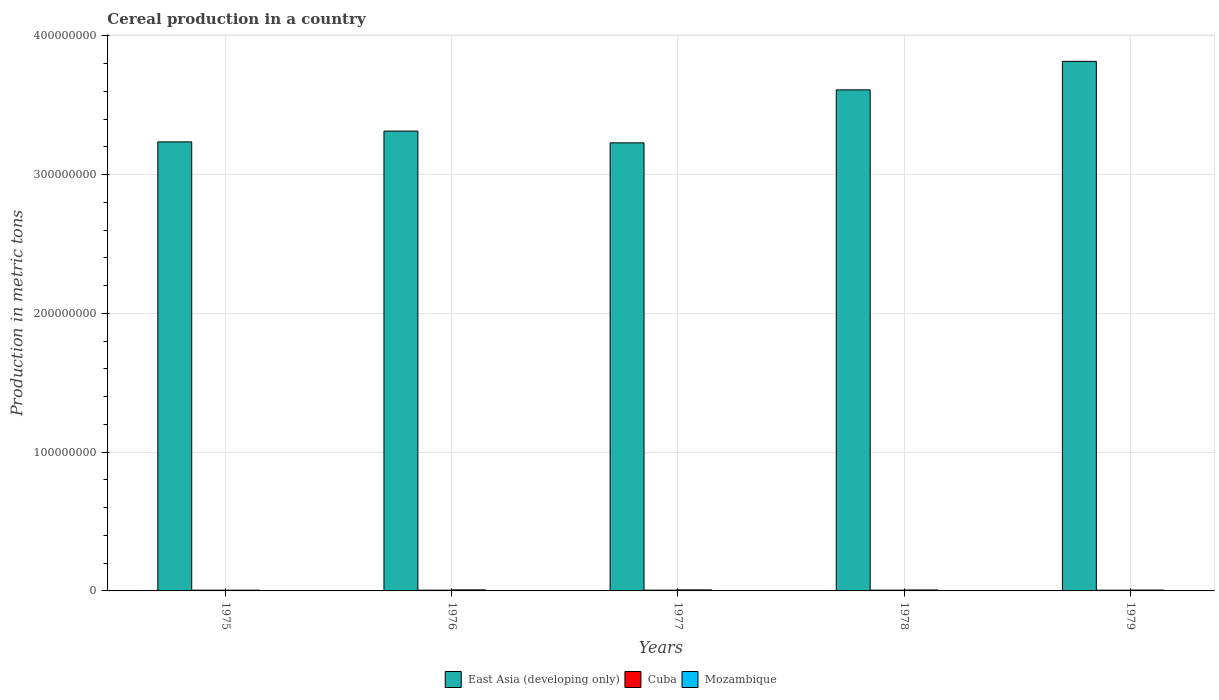Are the number of bars per tick equal to the number of legend labels?
Make the answer very short. Yes. What is the label of the 1st group of bars from the left?
Your answer should be compact. 1975. What is the total cereal production in East Asia (developing only) in 1976?
Your answer should be compact. 3.31e+08. Across all years, what is the maximum total cereal production in Cuba?
Provide a short and direct response. 5.54e+05. Across all years, what is the minimum total cereal production in East Asia (developing only)?
Provide a short and direct response. 3.23e+08. In which year was the total cereal production in East Asia (developing only) maximum?
Provide a succinct answer. 1979. In which year was the total cereal production in Mozambique minimum?
Keep it short and to the point. 1975. What is the total total cereal production in Cuba in the graph?
Your response must be concise. 2.71e+06. What is the difference between the total cereal production in Cuba in 1976 and that in 1978?
Provide a short and direct response. -7380. What is the difference between the total cereal production in East Asia (developing only) in 1977 and the total cereal production in Mozambique in 1978?
Give a very brief answer. 3.22e+08. What is the average total cereal production in Cuba per year?
Offer a very short reply. 5.43e+05. In the year 1975, what is the difference between the total cereal production in Mozambique and total cereal production in Cuba?
Offer a very short reply. 654. In how many years, is the total cereal production in Cuba greater than 220000000 metric tons?
Offer a very short reply. 0. What is the ratio of the total cereal production in East Asia (developing only) in 1976 to that in 1977?
Offer a very short reply. 1.03. Is the difference between the total cereal production in Mozambique in 1975 and 1977 greater than the difference between the total cereal production in Cuba in 1975 and 1977?
Keep it short and to the point. No. What is the difference between the highest and the second highest total cereal production in Mozambique?
Offer a very short reply. 1.80e+04. What is the difference between the highest and the lowest total cereal production in East Asia (developing only)?
Your answer should be compact. 5.87e+07. Is the sum of the total cereal production in Cuba in 1975 and 1976 greater than the maximum total cereal production in East Asia (developing only) across all years?
Make the answer very short. No. What does the 3rd bar from the left in 1978 represents?
Your answer should be compact. Mozambique. What does the 1st bar from the right in 1977 represents?
Offer a very short reply. Mozambique. Are all the bars in the graph horizontal?
Keep it short and to the point. No. How many years are there in the graph?
Your answer should be very brief. 5. What is the difference between two consecutive major ticks on the Y-axis?
Your answer should be compact. 1.00e+08. Are the values on the major ticks of Y-axis written in scientific E-notation?
Make the answer very short. No. Does the graph contain any zero values?
Give a very brief answer. No. How are the legend labels stacked?
Your answer should be very brief. Horizontal. What is the title of the graph?
Provide a succinct answer. Cereal production in a country. Does "Bolivia" appear as one of the legend labels in the graph?
Ensure brevity in your answer.  No. What is the label or title of the X-axis?
Your answer should be compact. Years. What is the label or title of the Y-axis?
Your answer should be compact. Production in metric tons. What is the Production in metric tons of East Asia (developing only) in 1975?
Your response must be concise. 3.24e+08. What is the Production in metric tons in Cuba in 1975?
Keep it short and to the point. 5.41e+05. What is the Production in metric tons in Mozambique in 1975?
Ensure brevity in your answer.  5.42e+05. What is the Production in metric tons of East Asia (developing only) in 1976?
Provide a short and direct response. 3.31e+08. What is the Production in metric tons in Cuba in 1976?
Your response must be concise. 5.46e+05. What is the Production in metric tons in Mozambique in 1976?
Provide a succinct answer. 7.56e+05. What is the Production in metric tons of East Asia (developing only) in 1977?
Give a very brief answer. 3.23e+08. What is the Production in metric tons in Cuba in 1977?
Your answer should be compact. 5.52e+05. What is the Production in metric tons of Mozambique in 1977?
Your response must be concise. 7.38e+05. What is the Production in metric tons of East Asia (developing only) in 1978?
Ensure brevity in your answer.  3.61e+08. What is the Production in metric tons in Cuba in 1978?
Ensure brevity in your answer.  5.54e+05. What is the Production in metric tons in Mozambique in 1978?
Give a very brief answer. 6.82e+05. What is the Production in metric tons of East Asia (developing only) in 1979?
Keep it short and to the point. 3.82e+08. What is the Production in metric tons in Cuba in 1979?
Offer a terse response. 5.21e+05. What is the Production in metric tons in Mozambique in 1979?
Ensure brevity in your answer.  6.22e+05. Across all years, what is the maximum Production in metric tons in East Asia (developing only)?
Offer a very short reply. 3.82e+08. Across all years, what is the maximum Production in metric tons in Cuba?
Offer a terse response. 5.54e+05. Across all years, what is the maximum Production in metric tons in Mozambique?
Your answer should be compact. 7.56e+05. Across all years, what is the minimum Production in metric tons in East Asia (developing only)?
Keep it short and to the point. 3.23e+08. Across all years, what is the minimum Production in metric tons in Cuba?
Give a very brief answer. 5.21e+05. Across all years, what is the minimum Production in metric tons of Mozambique?
Provide a succinct answer. 5.42e+05. What is the total Production in metric tons in East Asia (developing only) in the graph?
Ensure brevity in your answer.  1.72e+09. What is the total Production in metric tons in Cuba in the graph?
Your response must be concise. 2.71e+06. What is the total Production in metric tons in Mozambique in the graph?
Provide a short and direct response. 3.34e+06. What is the difference between the Production in metric tons in East Asia (developing only) in 1975 and that in 1976?
Offer a very short reply. -7.76e+06. What is the difference between the Production in metric tons of Cuba in 1975 and that in 1976?
Your answer should be very brief. -4832. What is the difference between the Production in metric tons of Mozambique in 1975 and that in 1976?
Offer a very short reply. -2.14e+05. What is the difference between the Production in metric tons in East Asia (developing only) in 1975 and that in 1977?
Provide a succinct answer. 6.87e+05. What is the difference between the Production in metric tons in Cuba in 1975 and that in 1977?
Your response must be concise. -1.05e+04. What is the difference between the Production in metric tons of Mozambique in 1975 and that in 1977?
Your response must be concise. -1.96e+05. What is the difference between the Production in metric tons in East Asia (developing only) in 1975 and that in 1978?
Your response must be concise. -3.75e+07. What is the difference between the Production in metric tons in Cuba in 1975 and that in 1978?
Your answer should be very brief. -1.22e+04. What is the difference between the Production in metric tons in East Asia (developing only) in 1975 and that in 1979?
Offer a very short reply. -5.80e+07. What is the difference between the Production in metric tons of Cuba in 1975 and that in 1979?
Provide a succinct answer. 2.01e+04. What is the difference between the Production in metric tons in Mozambique in 1975 and that in 1979?
Provide a succinct answer. -7.99e+04. What is the difference between the Production in metric tons in East Asia (developing only) in 1976 and that in 1977?
Offer a terse response. 8.45e+06. What is the difference between the Production in metric tons in Cuba in 1976 and that in 1977?
Ensure brevity in your answer.  -5696. What is the difference between the Production in metric tons of Mozambique in 1976 and that in 1977?
Provide a short and direct response. 1.80e+04. What is the difference between the Production in metric tons of East Asia (developing only) in 1976 and that in 1978?
Ensure brevity in your answer.  -2.97e+07. What is the difference between the Production in metric tons of Cuba in 1976 and that in 1978?
Your answer should be compact. -7380. What is the difference between the Production in metric tons of Mozambique in 1976 and that in 1978?
Your answer should be compact. 7.40e+04. What is the difference between the Production in metric tons in East Asia (developing only) in 1976 and that in 1979?
Provide a short and direct response. -5.03e+07. What is the difference between the Production in metric tons of Cuba in 1976 and that in 1979?
Provide a short and direct response. 2.50e+04. What is the difference between the Production in metric tons of Mozambique in 1976 and that in 1979?
Give a very brief answer. 1.34e+05. What is the difference between the Production in metric tons in East Asia (developing only) in 1977 and that in 1978?
Your response must be concise. -3.82e+07. What is the difference between the Production in metric tons of Cuba in 1977 and that in 1978?
Your answer should be compact. -1684. What is the difference between the Production in metric tons in Mozambique in 1977 and that in 1978?
Your answer should be very brief. 5.60e+04. What is the difference between the Production in metric tons of East Asia (developing only) in 1977 and that in 1979?
Provide a short and direct response. -5.87e+07. What is the difference between the Production in metric tons in Cuba in 1977 and that in 1979?
Give a very brief answer. 3.07e+04. What is the difference between the Production in metric tons of Mozambique in 1977 and that in 1979?
Provide a succinct answer. 1.16e+05. What is the difference between the Production in metric tons of East Asia (developing only) in 1978 and that in 1979?
Offer a very short reply. -2.06e+07. What is the difference between the Production in metric tons in Cuba in 1978 and that in 1979?
Make the answer very short. 3.24e+04. What is the difference between the Production in metric tons in Mozambique in 1978 and that in 1979?
Make the answer very short. 6.01e+04. What is the difference between the Production in metric tons of East Asia (developing only) in 1975 and the Production in metric tons of Cuba in 1976?
Offer a very short reply. 3.23e+08. What is the difference between the Production in metric tons in East Asia (developing only) in 1975 and the Production in metric tons in Mozambique in 1976?
Offer a very short reply. 3.23e+08. What is the difference between the Production in metric tons in Cuba in 1975 and the Production in metric tons in Mozambique in 1976?
Make the answer very short. -2.15e+05. What is the difference between the Production in metric tons in East Asia (developing only) in 1975 and the Production in metric tons in Cuba in 1977?
Make the answer very short. 3.23e+08. What is the difference between the Production in metric tons of East Asia (developing only) in 1975 and the Production in metric tons of Mozambique in 1977?
Your answer should be compact. 3.23e+08. What is the difference between the Production in metric tons of Cuba in 1975 and the Production in metric tons of Mozambique in 1977?
Offer a terse response. -1.97e+05. What is the difference between the Production in metric tons in East Asia (developing only) in 1975 and the Production in metric tons in Cuba in 1978?
Provide a short and direct response. 3.23e+08. What is the difference between the Production in metric tons in East Asia (developing only) in 1975 and the Production in metric tons in Mozambique in 1978?
Offer a very short reply. 3.23e+08. What is the difference between the Production in metric tons in Cuba in 1975 and the Production in metric tons in Mozambique in 1978?
Keep it short and to the point. -1.41e+05. What is the difference between the Production in metric tons of East Asia (developing only) in 1975 and the Production in metric tons of Cuba in 1979?
Provide a succinct answer. 3.23e+08. What is the difference between the Production in metric tons in East Asia (developing only) in 1975 and the Production in metric tons in Mozambique in 1979?
Give a very brief answer. 3.23e+08. What is the difference between the Production in metric tons of Cuba in 1975 and the Production in metric tons of Mozambique in 1979?
Keep it short and to the point. -8.06e+04. What is the difference between the Production in metric tons of East Asia (developing only) in 1976 and the Production in metric tons of Cuba in 1977?
Your response must be concise. 3.31e+08. What is the difference between the Production in metric tons in East Asia (developing only) in 1976 and the Production in metric tons in Mozambique in 1977?
Your answer should be very brief. 3.31e+08. What is the difference between the Production in metric tons in Cuba in 1976 and the Production in metric tons in Mozambique in 1977?
Offer a very short reply. -1.92e+05. What is the difference between the Production in metric tons of East Asia (developing only) in 1976 and the Production in metric tons of Cuba in 1978?
Keep it short and to the point. 3.31e+08. What is the difference between the Production in metric tons of East Asia (developing only) in 1976 and the Production in metric tons of Mozambique in 1978?
Give a very brief answer. 3.31e+08. What is the difference between the Production in metric tons of Cuba in 1976 and the Production in metric tons of Mozambique in 1978?
Keep it short and to the point. -1.36e+05. What is the difference between the Production in metric tons in East Asia (developing only) in 1976 and the Production in metric tons in Cuba in 1979?
Offer a very short reply. 3.31e+08. What is the difference between the Production in metric tons of East Asia (developing only) in 1976 and the Production in metric tons of Mozambique in 1979?
Your answer should be very brief. 3.31e+08. What is the difference between the Production in metric tons of Cuba in 1976 and the Production in metric tons of Mozambique in 1979?
Provide a short and direct response. -7.58e+04. What is the difference between the Production in metric tons of East Asia (developing only) in 1977 and the Production in metric tons of Cuba in 1978?
Provide a succinct answer. 3.22e+08. What is the difference between the Production in metric tons in East Asia (developing only) in 1977 and the Production in metric tons in Mozambique in 1978?
Make the answer very short. 3.22e+08. What is the difference between the Production in metric tons in Cuba in 1977 and the Production in metric tons in Mozambique in 1978?
Your response must be concise. -1.30e+05. What is the difference between the Production in metric tons in East Asia (developing only) in 1977 and the Production in metric tons in Cuba in 1979?
Your answer should be compact. 3.22e+08. What is the difference between the Production in metric tons in East Asia (developing only) in 1977 and the Production in metric tons in Mozambique in 1979?
Give a very brief answer. 3.22e+08. What is the difference between the Production in metric tons of Cuba in 1977 and the Production in metric tons of Mozambique in 1979?
Your answer should be very brief. -7.01e+04. What is the difference between the Production in metric tons in East Asia (developing only) in 1978 and the Production in metric tons in Cuba in 1979?
Offer a terse response. 3.60e+08. What is the difference between the Production in metric tons in East Asia (developing only) in 1978 and the Production in metric tons in Mozambique in 1979?
Your answer should be compact. 3.60e+08. What is the difference between the Production in metric tons in Cuba in 1978 and the Production in metric tons in Mozambique in 1979?
Provide a succinct answer. -6.84e+04. What is the average Production in metric tons in East Asia (developing only) per year?
Make the answer very short. 3.44e+08. What is the average Production in metric tons of Cuba per year?
Give a very brief answer. 5.43e+05. What is the average Production in metric tons in Mozambique per year?
Provide a short and direct response. 6.68e+05. In the year 1975, what is the difference between the Production in metric tons in East Asia (developing only) and Production in metric tons in Cuba?
Offer a very short reply. 3.23e+08. In the year 1975, what is the difference between the Production in metric tons of East Asia (developing only) and Production in metric tons of Mozambique?
Make the answer very short. 3.23e+08. In the year 1975, what is the difference between the Production in metric tons of Cuba and Production in metric tons of Mozambique?
Offer a very short reply. -654. In the year 1976, what is the difference between the Production in metric tons in East Asia (developing only) and Production in metric tons in Cuba?
Provide a succinct answer. 3.31e+08. In the year 1976, what is the difference between the Production in metric tons of East Asia (developing only) and Production in metric tons of Mozambique?
Keep it short and to the point. 3.31e+08. In the year 1976, what is the difference between the Production in metric tons in Cuba and Production in metric tons in Mozambique?
Provide a short and direct response. -2.10e+05. In the year 1977, what is the difference between the Production in metric tons in East Asia (developing only) and Production in metric tons in Cuba?
Offer a very short reply. 3.22e+08. In the year 1977, what is the difference between the Production in metric tons in East Asia (developing only) and Production in metric tons in Mozambique?
Provide a succinct answer. 3.22e+08. In the year 1977, what is the difference between the Production in metric tons in Cuba and Production in metric tons in Mozambique?
Offer a very short reply. -1.86e+05. In the year 1978, what is the difference between the Production in metric tons in East Asia (developing only) and Production in metric tons in Cuba?
Offer a very short reply. 3.60e+08. In the year 1978, what is the difference between the Production in metric tons in East Asia (developing only) and Production in metric tons in Mozambique?
Your answer should be compact. 3.60e+08. In the year 1978, what is the difference between the Production in metric tons in Cuba and Production in metric tons in Mozambique?
Provide a short and direct response. -1.28e+05. In the year 1979, what is the difference between the Production in metric tons of East Asia (developing only) and Production in metric tons of Cuba?
Your answer should be compact. 3.81e+08. In the year 1979, what is the difference between the Production in metric tons in East Asia (developing only) and Production in metric tons in Mozambique?
Offer a very short reply. 3.81e+08. In the year 1979, what is the difference between the Production in metric tons of Cuba and Production in metric tons of Mozambique?
Your answer should be compact. -1.01e+05. What is the ratio of the Production in metric tons of East Asia (developing only) in 1975 to that in 1976?
Offer a very short reply. 0.98. What is the ratio of the Production in metric tons in Mozambique in 1975 to that in 1976?
Keep it short and to the point. 0.72. What is the ratio of the Production in metric tons in East Asia (developing only) in 1975 to that in 1977?
Your answer should be very brief. 1. What is the ratio of the Production in metric tons of Cuba in 1975 to that in 1977?
Make the answer very short. 0.98. What is the ratio of the Production in metric tons in Mozambique in 1975 to that in 1977?
Your response must be concise. 0.73. What is the ratio of the Production in metric tons of East Asia (developing only) in 1975 to that in 1978?
Your answer should be compact. 0.9. What is the ratio of the Production in metric tons of Cuba in 1975 to that in 1978?
Give a very brief answer. 0.98. What is the ratio of the Production in metric tons in Mozambique in 1975 to that in 1978?
Your answer should be very brief. 0.79. What is the ratio of the Production in metric tons in East Asia (developing only) in 1975 to that in 1979?
Offer a terse response. 0.85. What is the ratio of the Production in metric tons of Cuba in 1975 to that in 1979?
Your answer should be compact. 1.04. What is the ratio of the Production in metric tons of Mozambique in 1975 to that in 1979?
Provide a succinct answer. 0.87. What is the ratio of the Production in metric tons in East Asia (developing only) in 1976 to that in 1977?
Make the answer very short. 1.03. What is the ratio of the Production in metric tons of Mozambique in 1976 to that in 1977?
Make the answer very short. 1.02. What is the ratio of the Production in metric tons of East Asia (developing only) in 1976 to that in 1978?
Keep it short and to the point. 0.92. What is the ratio of the Production in metric tons of Cuba in 1976 to that in 1978?
Offer a terse response. 0.99. What is the ratio of the Production in metric tons of Mozambique in 1976 to that in 1978?
Ensure brevity in your answer.  1.11. What is the ratio of the Production in metric tons of East Asia (developing only) in 1976 to that in 1979?
Give a very brief answer. 0.87. What is the ratio of the Production in metric tons in Cuba in 1976 to that in 1979?
Your answer should be very brief. 1.05. What is the ratio of the Production in metric tons in Mozambique in 1976 to that in 1979?
Provide a succinct answer. 1.22. What is the ratio of the Production in metric tons of East Asia (developing only) in 1977 to that in 1978?
Your response must be concise. 0.89. What is the ratio of the Production in metric tons of Cuba in 1977 to that in 1978?
Offer a very short reply. 1. What is the ratio of the Production in metric tons of Mozambique in 1977 to that in 1978?
Your response must be concise. 1.08. What is the ratio of the Production in metric tons of East Asia (developing only) in 1977 to that in 1979?
Offer a terse response. 0.85. What is the ratio of the Production in metric tons of Cuba in 1977 to that in 1979?
Offer a terse response. 1.06. What is the ratio of the Production in metric tons of Mozambique in 1977 to that in 1979?
Ensure brevity in your answer.  1.19. What is the ratio of the Production in metric tons in East Asia (developing only) in 1978 to that in 1979?
Offer a very short reply. 0.95. What is the ratio of the Production in metric tons in Cuba in 1978 to that in 1979?
Your answer should be very brief. 1.06. What is the ratio of the Production in metric tons of Mozambique in 1978 to that in 1979?
Give a very brief answer. 1.1. What is the difference between the highest and the second highest Production in metric tons of East Asia (developing only)?
Provide a succinct answer. 2.06e+07. What is the difference between the highest and the second highest Production in metric tons in Cuba?
Keep it short and to the point. 1684. What is the difference between the highest and the second highest Production in metric tons of Mozambique?
Offer a terse response. 1.80e+04. What is the difference between the highest and the lowest Production in metric tons in East Asia (developing only)?
Provide a succinct answer. 5.87e+07. What is the difference between the highest and the lowest Production in metric tons in Cuba?
Offer a terse response. 3.24e+04. What is the difference between the highest and the lowest Production in metric tons in Mozambique?
Keep it short and to the point. 2.14e+05. 